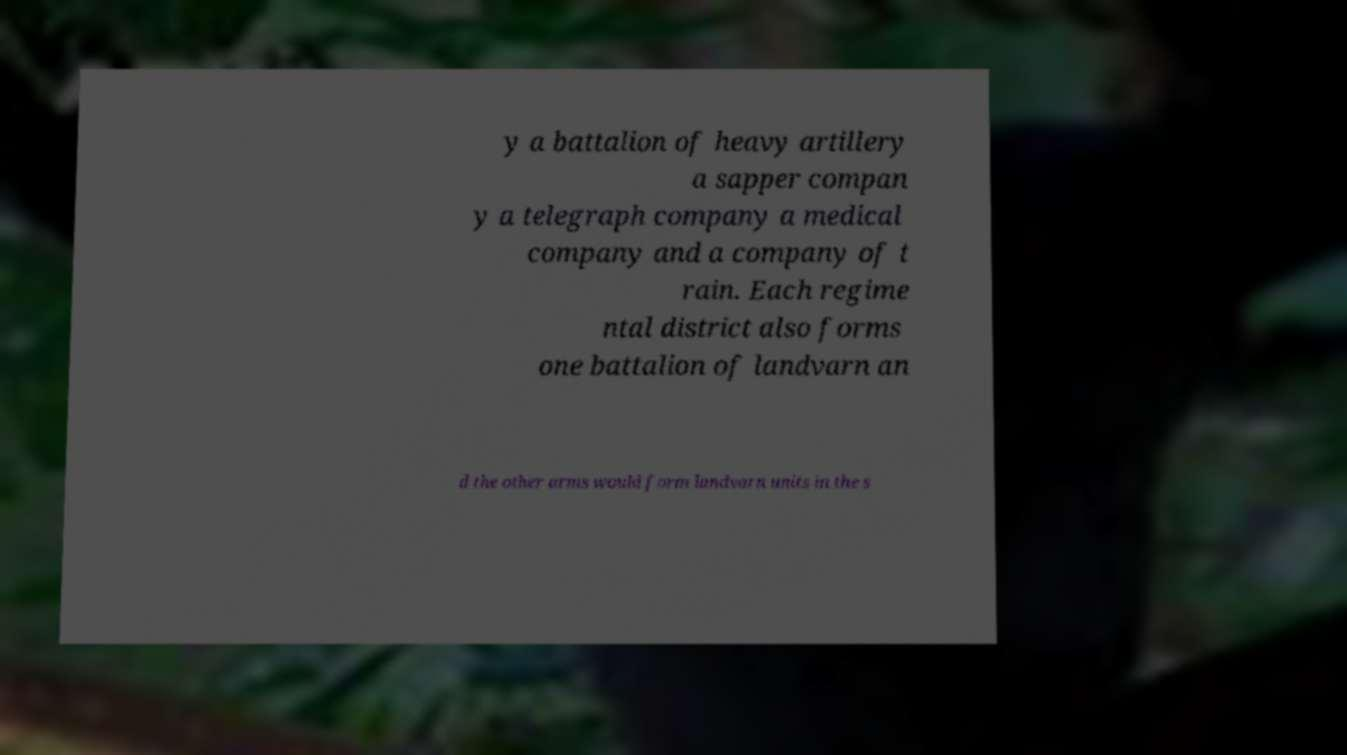There's text embedded in this image that I need extracted. Can you transcribe it verbatim? y a battalion of heavy artillery a sapper compan y a telegraph company a medical company and a company of t rain. Each regime ntal district also forms one battalion of landvarn an d the other arms would form landvarn units in the s 